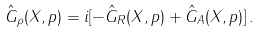Convert formula to latex. <formula><loc_0><loc_0><loc_500><loc_500>\hat { G } _ { \rho } ( X , p ) & = i [ - \hat { G } _ { R } ( X , p ) + \hat { G } _ { A } ( X , p ) ] \, .</formula> 